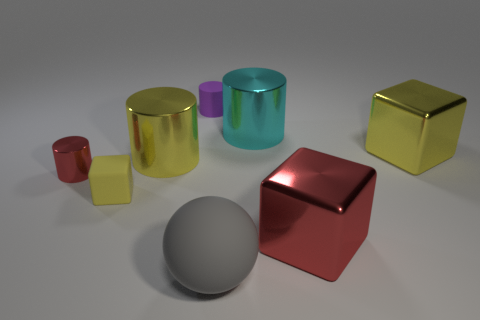Are there any other things that have the same shape as the big gray thing?
Offer a very short reply. No. Do the red cylinder and the matte sphere have the same size?
Your answer should be very brief. No. Is the material of the ball right of the purple matte cylinder the same as the small purple object?
Ensure brevity in your answer.  Yes. How many large yellow objects are on the right side of the yellow block that is to the right of the red metal thing that is right of the red cylinder?
Make the answer very short. 0. Does the red metallic object to the left of the purple matte object have the same shape as the small purple thing?
Offer a very short reply. Yes. What number of things are either matte cylinders or metallic things that are on the left side of the gray sphere?
Offer a very short reply. 3. Is the number of cyan shiny objects right of the rubber cylinder greater than the number of blue metal cubes?
Provide a short and direct response. Yes. Are there the same number of big yellow cylinders on the left side of the tiny yellow thing and matte balls on the right side of the purple cylinder?
Give a very brief answer. No. There is a cube that is left of the big rubber sphere; is there a tiny object that is to the left of it?
Keep it short and to the point. Yes. What is the shape of the gray matte thing?
Give a very brief answer. Sphere. 